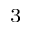<formula> <loc_0><loc_0><loc_500><loc_500>^ { 3 }</formula> 